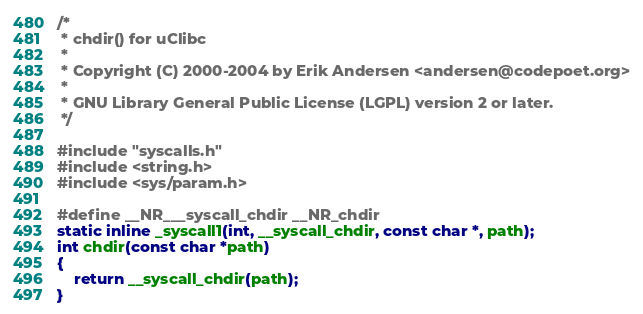Convert code to text. <code><loc_0><loc_0><loc_500><loc_500><_C_>/*
 * chdir() for uClibc
 *
 * Copyright (C) 2000-2004 by Erik Andersen <andersen@codepoet.org>
 *
 * GNU Library General Public License (LGPL) version 2 or later.
 */

#include "syscalls.h"
#include <string.h>
#include <sys/param.h>

#define __NR___syscall_chdir __NR_chdir
static inline _syscall1(int, __syscall_chdir, const char *, path);
int chdir(const char *path)
{
	return __syscall_chdir(path);
}

</code> 